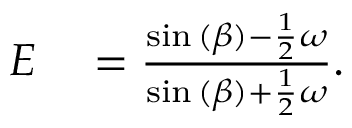Convert formula to latex. <formula><loc_0><loc_0><loc_500><loc_500>\begin{array} { r l } { E } & = \frac { \sin { ( \beta ) } - \frac { 1 } { 2 } \omega } { \sin { ( \beta ) } + \frac { 1 } { 2 } \omega } . } \end{array}</formula> 